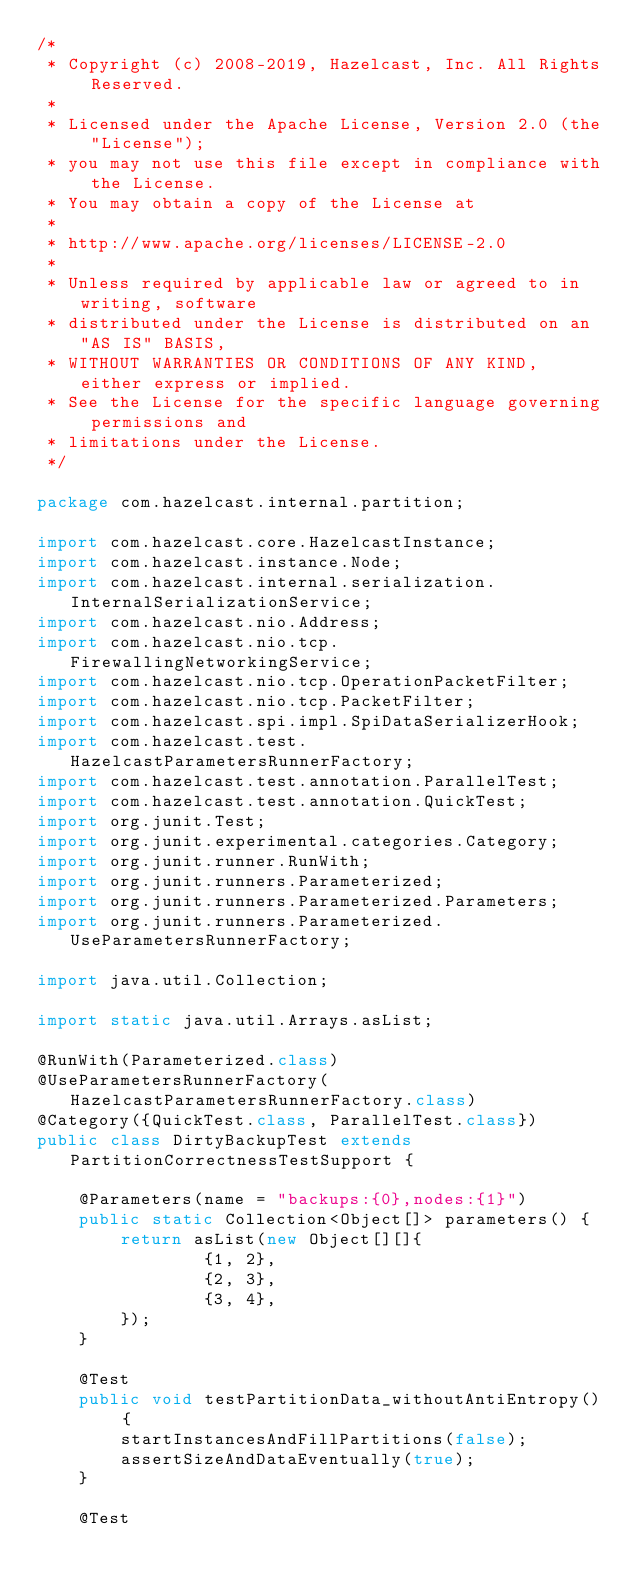<code> <loc_0><loc_0><loc_500><loc_500><_Java_>/*
 * Copyright (c) 2008-2019, Hazelcast, Inc. All Rights Reserved.
 *
 * Licensed under the Apache License, Version 2.0 (the "License");
 * you may not use this file except in compliance with the License.
 * You may obtain a copy of the License at
 *
 * http://www.apache.org/licenses/LICENSE-2.0
 *
 * Unless required by applicable law or agreed to in writing, software
 * distributed under the License is distributed on an "AS IS" BASIS,
 * WITHOUT WARRANTIES OR CONDITIONS OF ANY KIND, either express or implied.
 * See the License for the specific language governing permissions and
 * limitations under the License.
 */

package com.hazelcast.internal.partition;

import com.hazelcast.core.HazelcastInstance;
import com.hazelcast.instance.Node;
import com.hazelcast.internal.serialization.InternalSerializationService;
import com.hazelcast.nio.Address;
import com.hazelcast.nio.tcp.FirewallingNetworkingService;
import com.hazelcast.nio.tcp.OperationPacketFilter;
import com.hazelcast.nio.tcp.PacketFilter;
import com.hazelcast.spi.impl.SpiDataSerializerHook;
import com.hazelcast.test.HazelcastParametersRunnerFactory;
import com.hazelcast.test.annotation.ParallelTest;
import com.hazelcast.test.annotation.QuickTest;
import org.junit.Test;
import org.junit.experimental.categories.Category;
import org.junit.runner.RunWith;
import org.junit.runners.Parameterized;
import org.junit.runners.Parameterized.Parameters;
import org.junit.runners.Parameterized.UseParametersRunnerFactory;

import java.util.Collection;

import static java.util.Arrays.asList;

@RunWith(Parameterized.class)
@UseParametersRunnerFactory(HazelcastParametersRunnerFactory.class)
@Category({QuickTest.class, ParallelTest.class})
public class DirtyBackupTest extends PartitionCorrectnessTestSupport {

    @Parameters(name = "backups:{0},nodes:{1}")
    public static Collection<Object[]> parameters() {
        return asList(new Object[][]{
                {1, 2},
                {2, 3},
                {3, 4},
        });
    }

    @Test
    public void testPartitionData_withoutAntiEntropy() {
        startInstancesAndFillPartitions(false);
        assertSizeAndDataEventually(true);
    }

    @Test</code> 